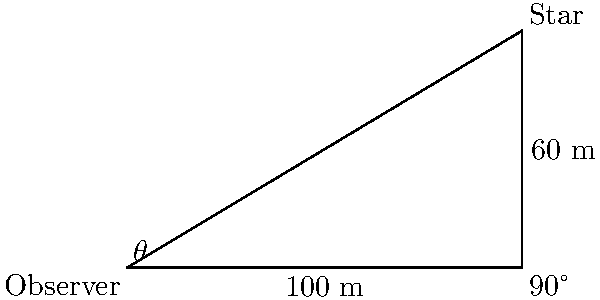As you gaze at the night sky, contemplating the divine inspiration for your next song, you spot a particularly bright star. You decide to calculate its angle of elevation as a metaphor for spiritual ascension. Standing on level ground, you measure the distance to a point directly beneath the star to be 100 meters. Your friend, who is 60 meters taller than you, can touch the star if they reach out. What is the angle of elevation $\theta$ to the star from your position? Let's approach this step-by-step:

1) The scenario forms a right-angled triangle, where:
   - The base of the triangle is 100 meters (your distance from the point beneath the star)
   - The height of the triangle is 60 meters (your friend's height difference)
   - The angle we're looking for is $\theta$ at the base of the triangle

2) In a right-angled triangle, we can use the tangent function to find the angle:

   $\tan(\theta) = \frac{\text{opposite}}{\text{adjacent}} = \frac{\text{height}}{\text{base}}$

3) Substituting our values:

   $\tan(\theta) = \frac{60}{100} = 0.6$

4) To find $\theta$, we need to use the inverse tangent (arctan or $\tan^{-1}$):

   $\theta = \tan^{-1}(0.6)$

5) Using a calculator or trigonometric tables:

   $\theta \approx 30.96^\circ$

This angle represents the spiritual elevation you're seeking in your songwriting, symbolizing the connection between earthly experiences and celestial inspiration.
Answer: $30.96^\circ$ 